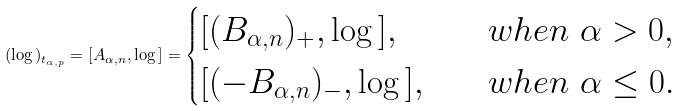<formula> <loc_0><loc_0><loc_500><loc_500>( \log \L ) _ { t _ { \alpha , p } } = [ A _ { \alpha , n } , \log \L ] = \begin{cases} [ ( B _ { \alpha , n } ) _ { + } , \log \L ] , \quad & w h e n \ \alpha > 0 , \\ [ ( - B _ { \alpha , n } ) _ { - } , \log \L ] , \quad & w h e n \ \alpha \leq 0 . \end{cases}</formula> 